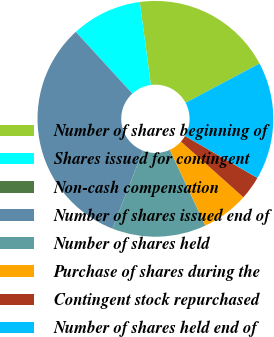<chart> <loc_0><loc_0><loc_500><loc_500><pie_chart><fcel>Number of shares beginning of<fcel>Shares issued for contingent<fcel>Non-cash compensation<fcel>Number of shares issued end of<fcel>Number of shares held<fcel>Purchase of shares during the<fcel>Contingent stock repurchased<fcel>Number of shares held end of<nl><fcel>19.35%<fcel>9.68%<fcel>0.0%<fcel>32.26%<fcel>12.9%<fcel>6.45%<fcel>3.23%<fcel>16.13%<nl></chart> 